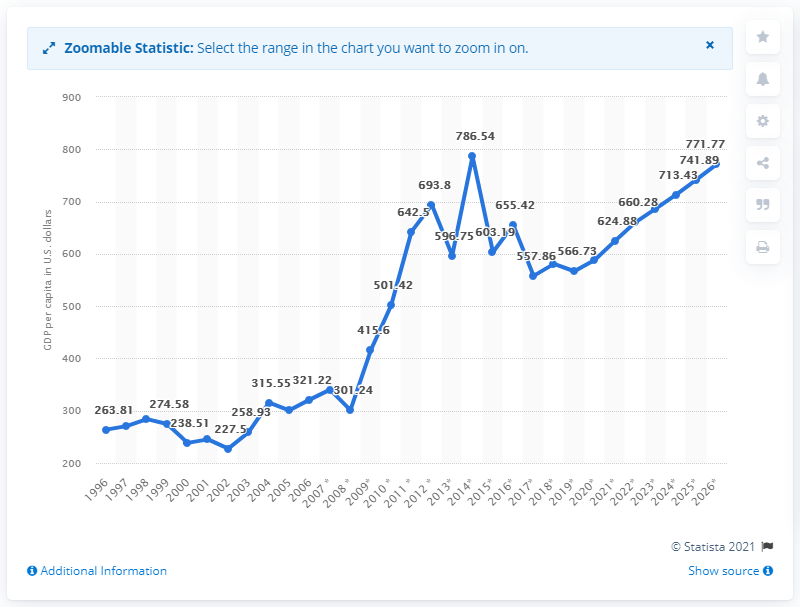List a handful of essential elements in this visual. In 2019, the GDP per capita in Eritrea was 566.73. 